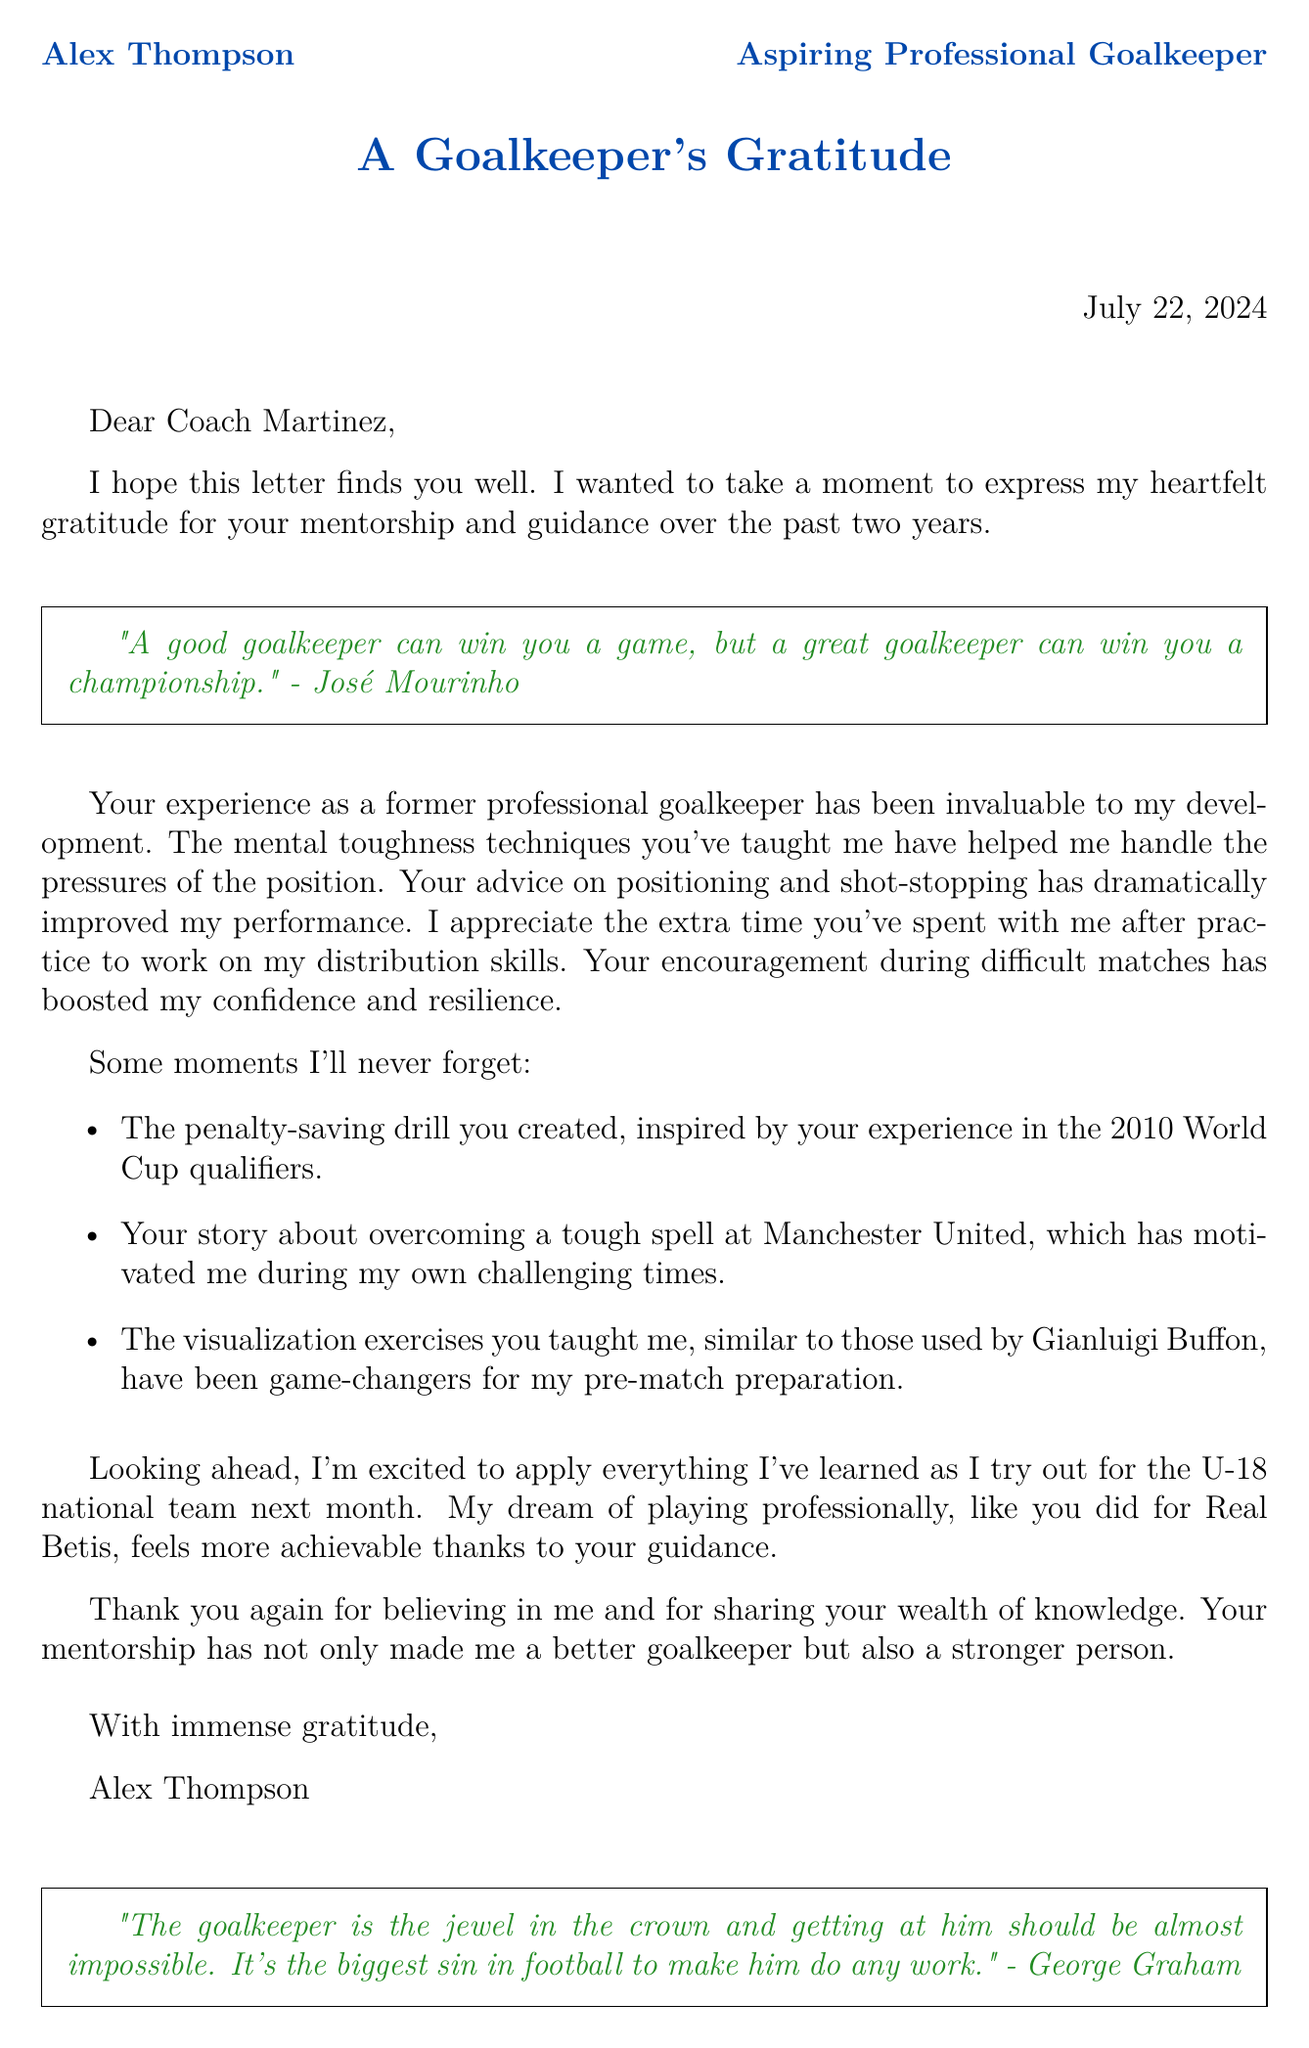What is the name of the coach? The coach's name is mentioned at the beginning of the letter.
Answer: Coach Martinez How long did the mentorship last? The duration of mentorship is stated in the letter.
Answer: 2 years What skill improved through extra practice after training? The letter mentions specific skills that were improved through extra practice.
Answer: Distribution skills Which club did the coach play for? The letter lists the former clubs in the coach's background.
Answer: Real Betis What upcoming event does Alex mention? The letter indicates a future goal of Alex related to his career.
Answer: U-18 national team tryout What is Alex's dream as stated in the letter? The letter reveals Alex's aspiration regarding his career.
Answer: Playing professionally What type of exercises were described as game-changers? The letter states a type of exercises that significantly helped Alex.
Answer: Visualization exercises Who is quoted at the beginning of the letter? The first quote in the letter is attributed to a well-known coach.
Answer: José Mourinho 